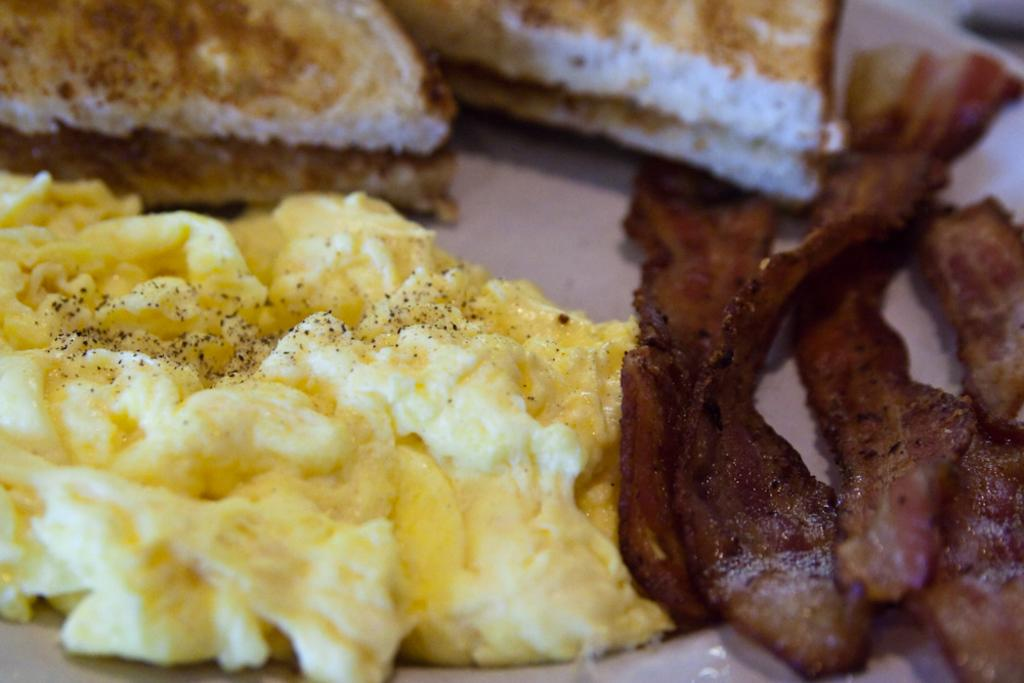What types of food can be seen in the image? There are different types of food in the image. Can you describe the colors of the food? The colors of the food include yellow, brown, and white. How many family members are present in the image? There is no indication of family members in the image; it only shows different types of food. What position does the stocking hold in the image? There is no stocking present in the image. 